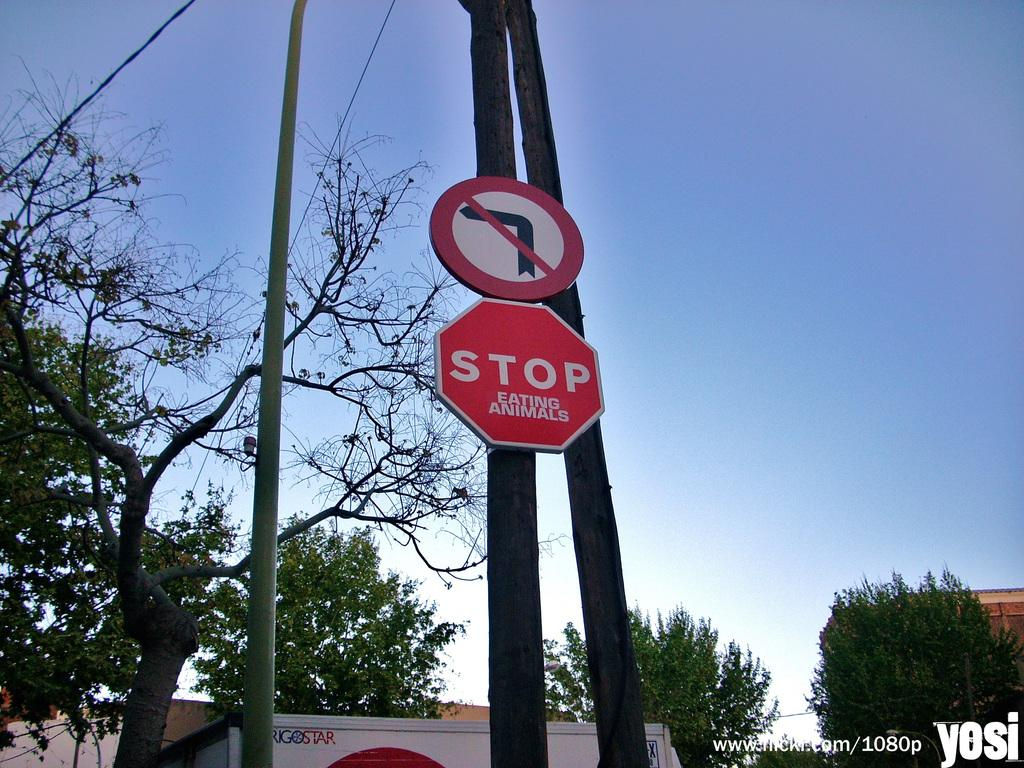Provide a one-sentence caption for the provided image. a stop sign that is below a no turn arrow. 